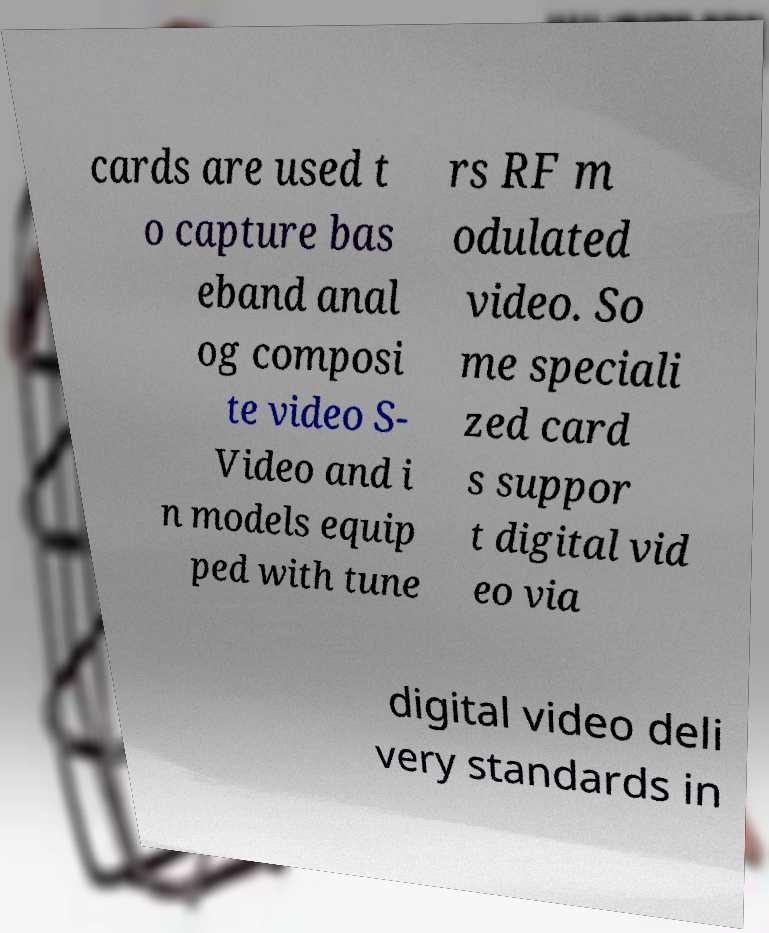There's text embedded in this image that I need extracted. Can you transcribe it verbatim? cards are used t o capture bas eband anal og composi te video S- Video and i n models equip ped with tune rs RF m odulated video. So me speciali zed card s suppor t digital vid eo via digital video deli very standards in 